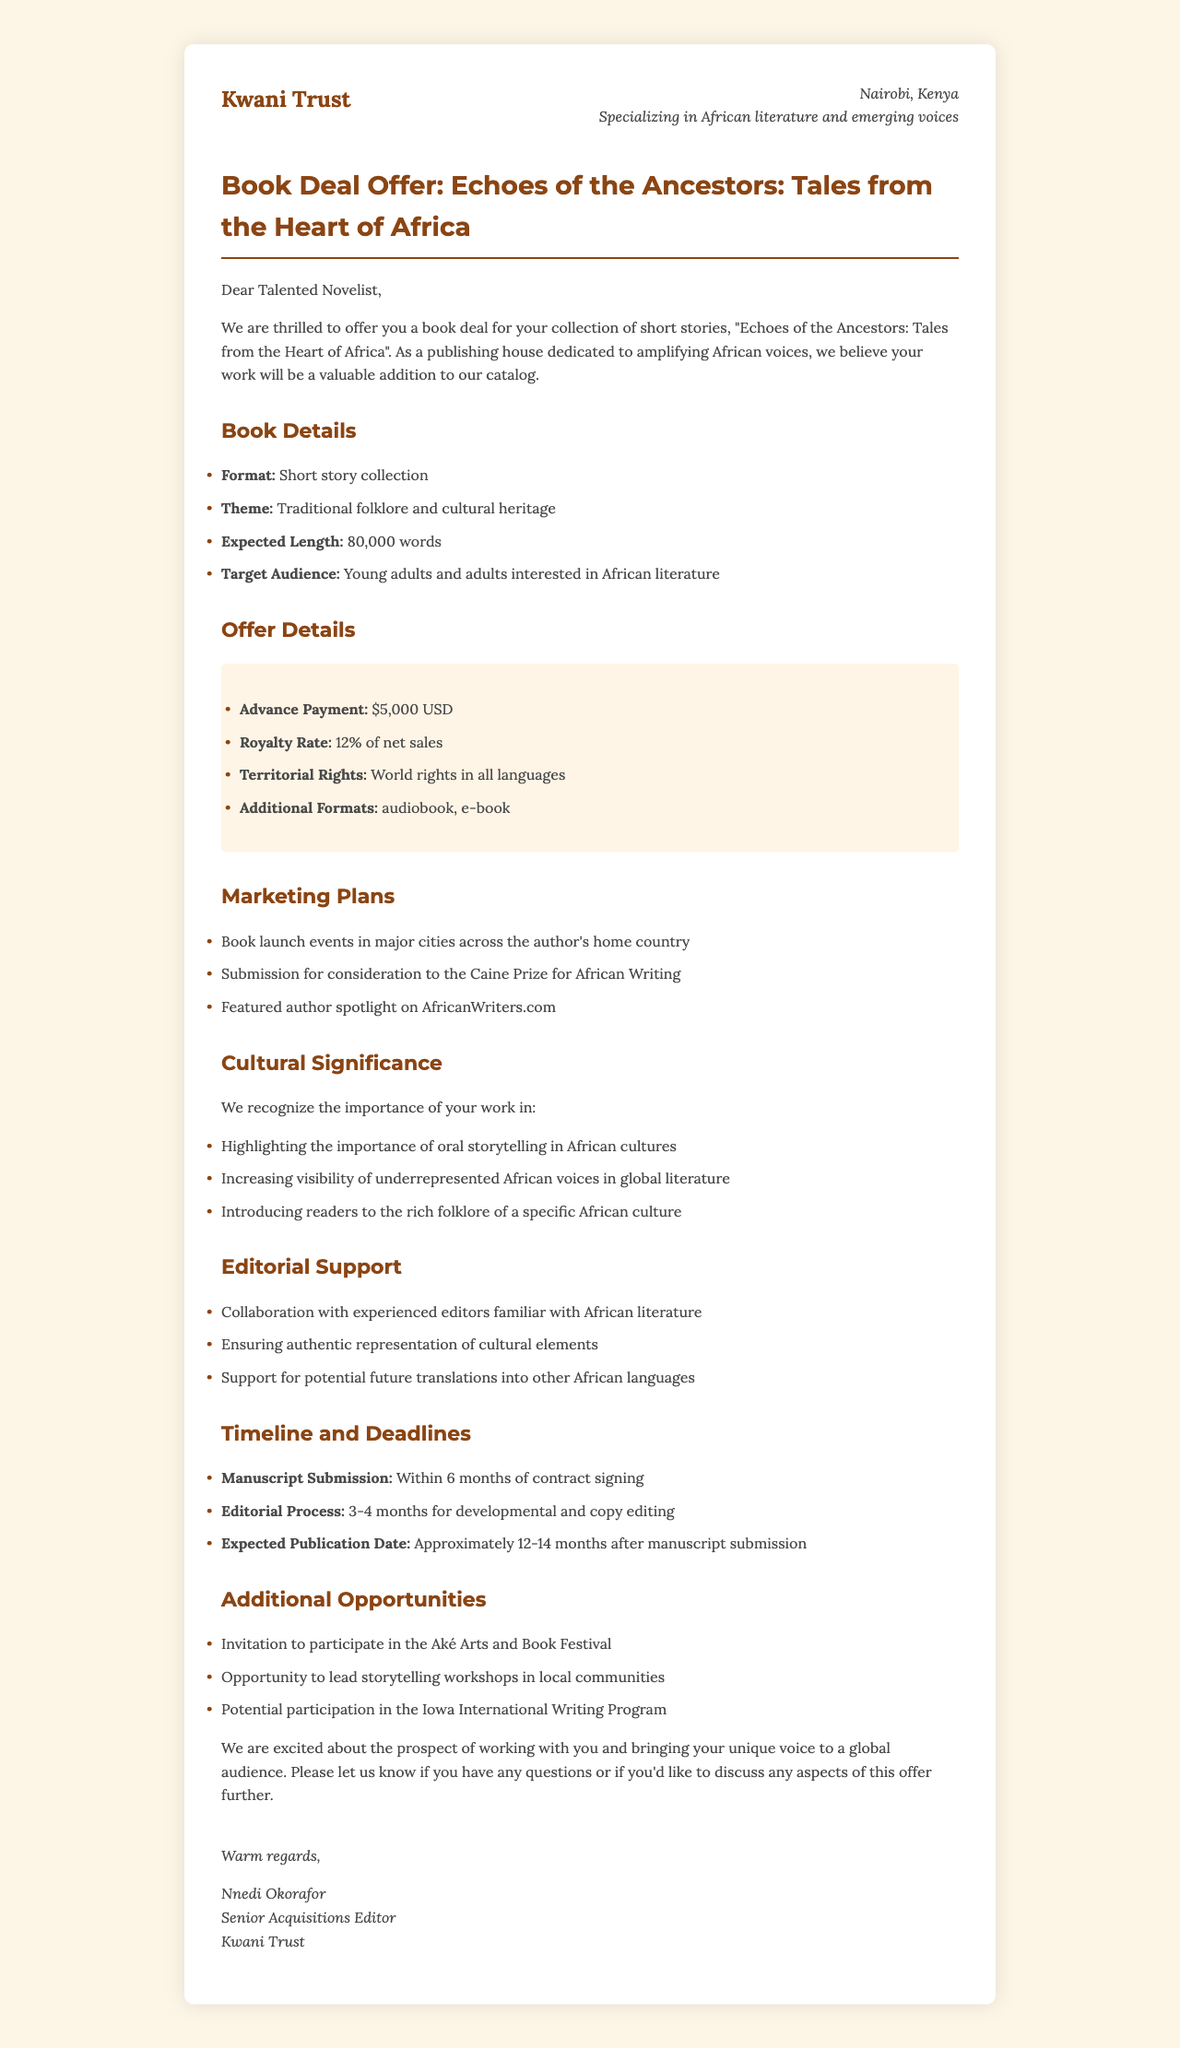What is the name of the publishing house? The publishing house is mentioned at the beginning of the document as the one making the offer.
Answer: Kwani Trust Who is the senior acquisitions editor? The document specifies who the editor is and their position within the publishing house.
Answer: Nnedi Okorafor What is the advance payment amount? The advance payment amount is clearly listed in the offer details section of the document.
Answer: $5,000 USD What is the expected length of the manuscript? The expected length of the manuscript is provided in the book details section for clarity.
Answer: 80,000 words Which prize will the book be submitted for consideration? The international exposure marketing plan mentions a specific prize for submissions.
Answer: Caine Prize for African Writing What type of additional formats are offered? The document lists the available additional formats included in the offer details.
Answer: audiobook, e-book What does the cultural significance section highlight? This section discusses the value of the author's work, linking it to the preservation of culture.
Answer: Importance of oral storytelling What is the manuscript submission deadline? The timeline and deadlines section specifies when the manuscript needs to be submitted.
Answer: Within 6 months of contract signing What opportunity involves leading workshops? The document describes a specific opportunity related to community engagements.
Answer: Writing workshops 